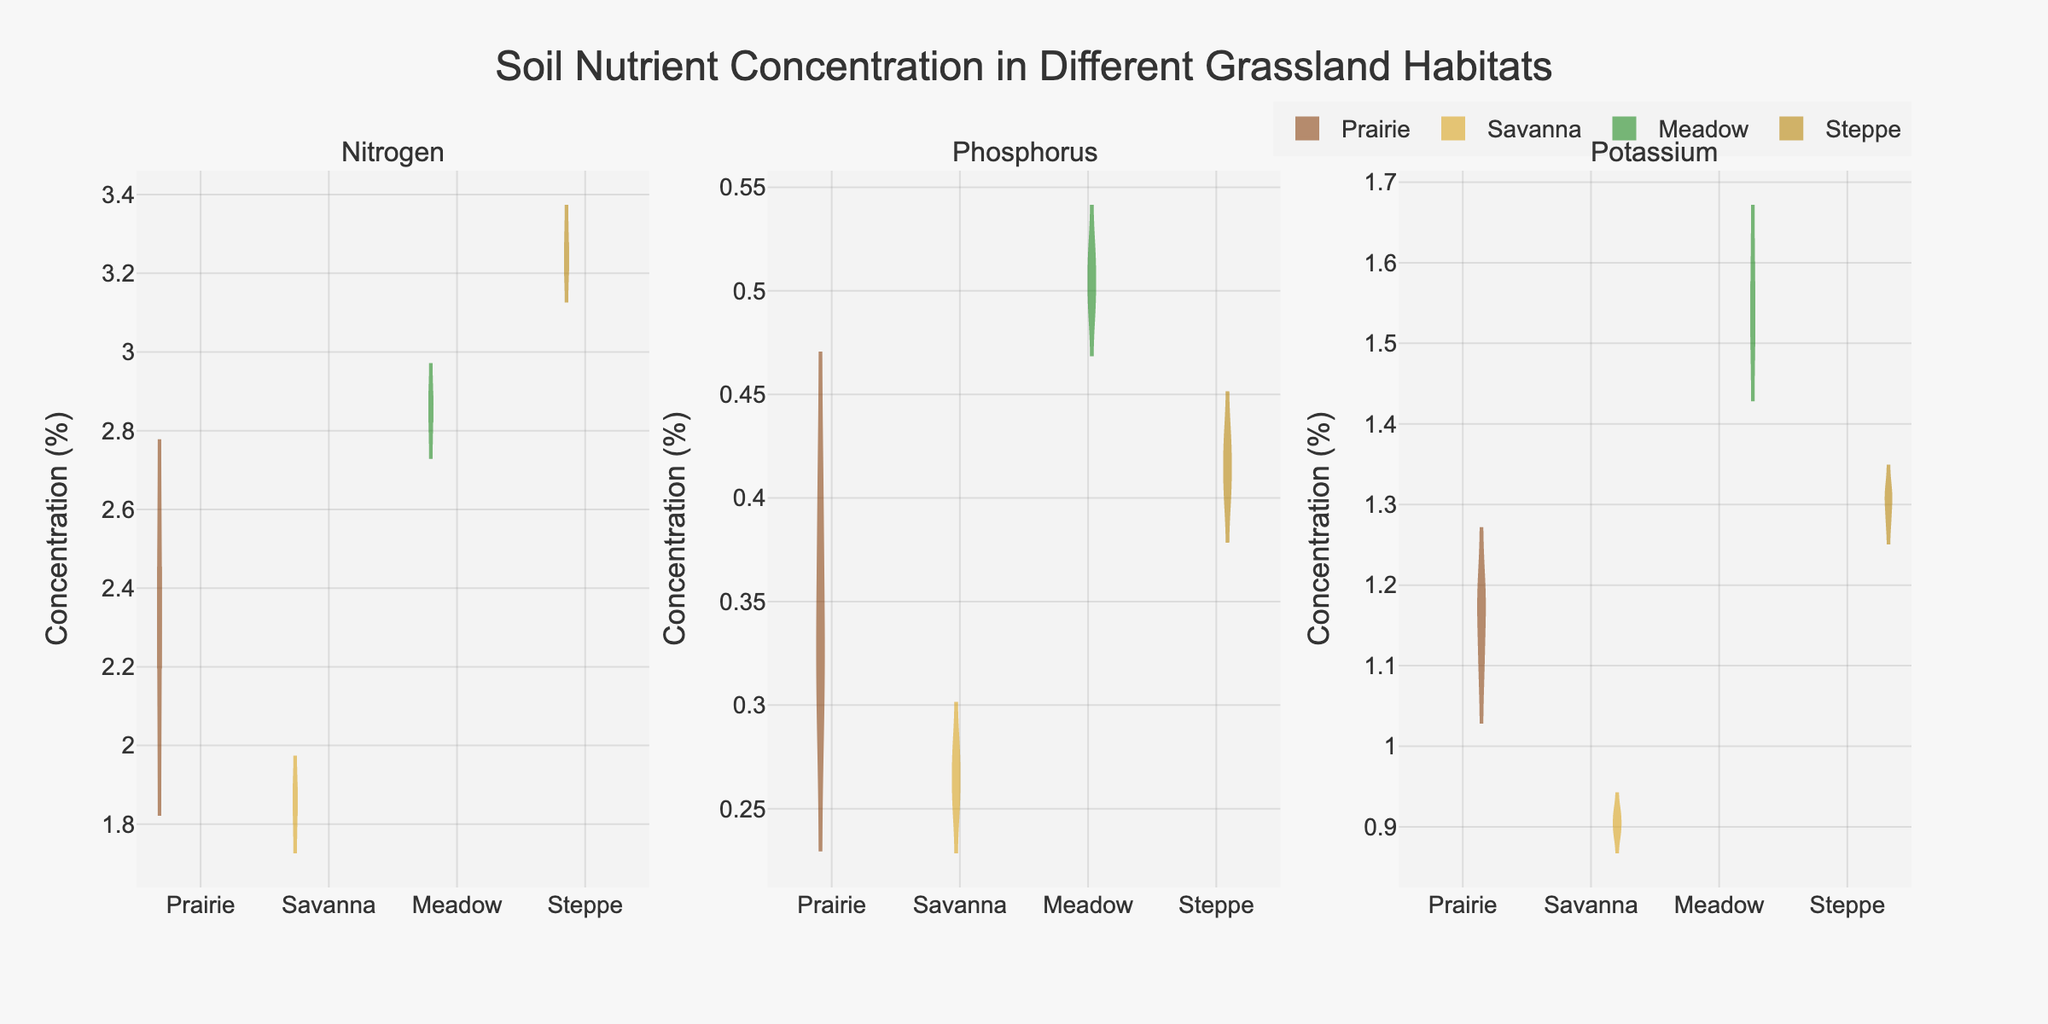How many habitats are displayed in the figure? The figure presents violin plots for four different habitats: Prairie, Savanna, Meadow, and Steppe.
Answer: Four What is the title of the figure? The title is displayed at the top of the figure. It reads: "Soil Nutrient Concentration in Different Grassland Habitats".
Answer: Soil Nutrient Concentration in Different Grassland Habitats Which habitat has the highest median concentration of Nitrogen? To find the highest median concentration of Nitrogen, look at the median lines (typically the white dot or small line) within the "Nitrogen" subplot. The Steppe habitat shows the highest median concentration.
Answer: Steppe For the nutrient Phosphorus, which habitat shows the lowest median concentration? In the "Phosphorus" subplot, the median for each habitat's violin plot can be compared. The Savanna habitat shows the lowest median concentration.
Answer: Savanna Compare the spread (range) of Potassium concentrations between Prairie and Meadow. Which one is larger? By examining the vertical span of the violin plots in the "Potassium" subplot, the edges extend further for the Meadow, indicating a larger spread in concentration.
Answer: Meadow Which nutrient shows the most distinct separation in concentrations between different habitats? This can be determined by comparing the overlap or lack thereof between the violin plots in each subplot. Nitrogen shows the most distinct separation, with each habitat's plot noticeably separated from the others.
Answer: Nitrogen Are any habitats' nutrient concentrations close to a uniform distribution? To spot a near-uniform distribution, a flatter and wider violin shape can be observed. For Potassium in the Prairie, the distribution appears more even compared to others.
Answer: Prairie for Potassium Which habitat has the largest mean Nitrogen concentration? The mean lines (often a dashed line) in the "Nitrogen" subplot display this. Steppe has the highest mean concentration for Nitrogen.
Answer: Steppe What is the order of habitats from highest to lowest median concentration of Phosphorus? By examining the median lines within the "Phosphorus" subplot, the habitats can be ranked as follows: Meadow, Steppe, Prairie, Savanna.
Answer: Meadow, Steppe, Prairie, Savanna 